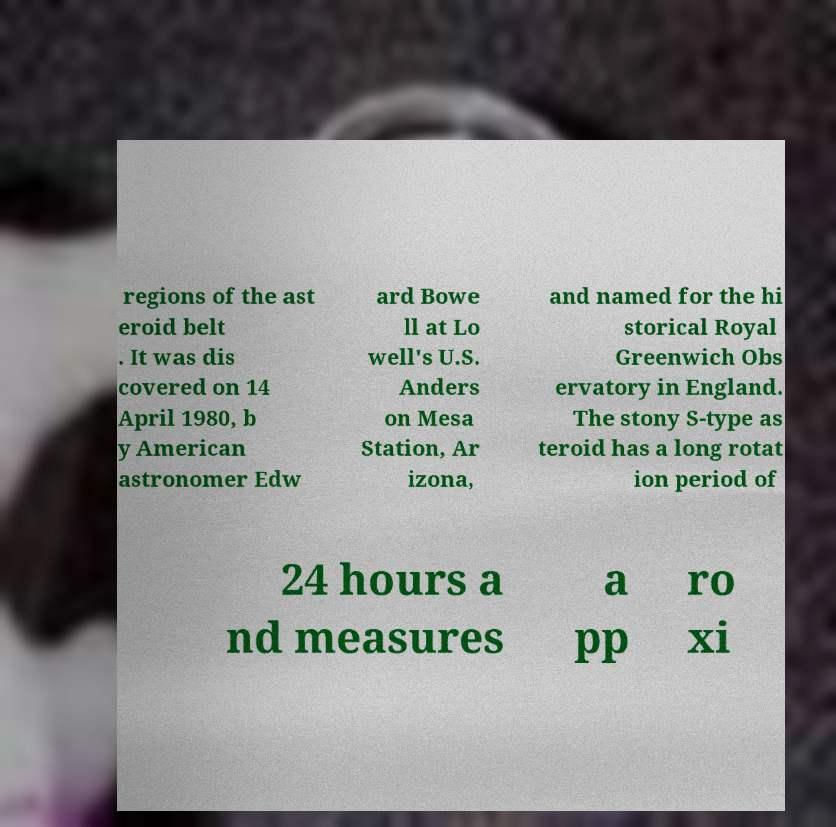Could you extract and type out the text from this image? regions of the ast eroid belt . It was dis covered on 14 April 1980, b y American astronomer Edw ard Bowe ll at Lo well's U.S. Anders on Mesa Station, Ar izona, and named for the hi storical Royal Greenwich Obs ervatory in England. The stony S-type as teroid has a long rotat ion period of 24 hours a nd measures a pp ro xi 